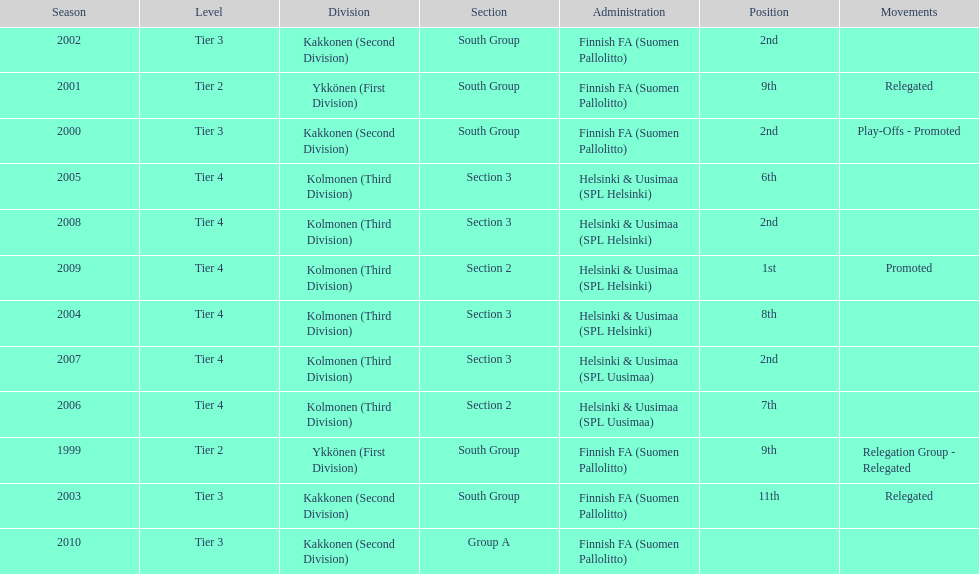Which was the only kolmonen whose movements were promoted? 2009. 